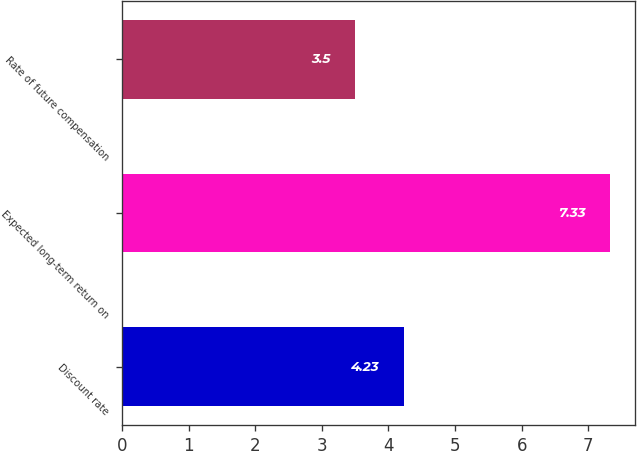<chart> <loc_0><loc_0><loc_500><loc_500><bar_chart><fcel>Discount rate<fcel>Expected long-term return on<fcel>Rate of future compensation<nl><fcel>4.23<fcel>7.33<fcel>3.5<nl></chart> 